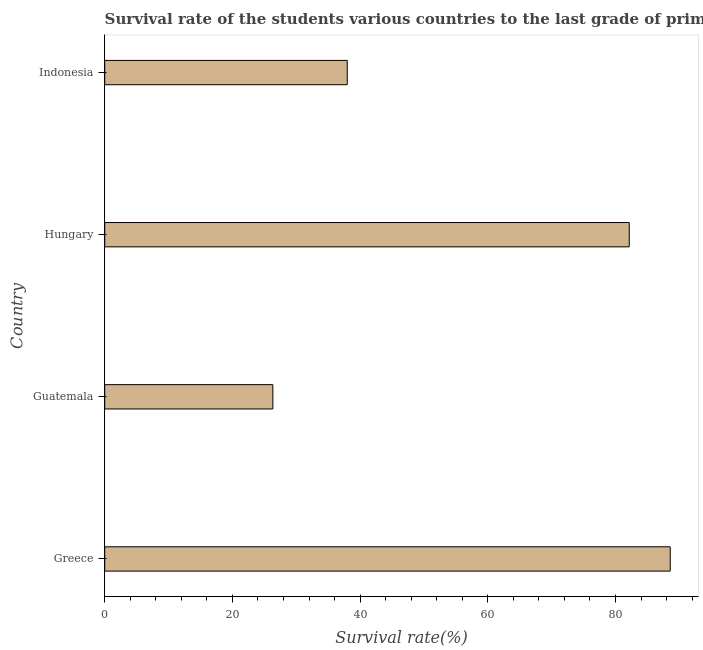Does the graph contain any zero values?
Keep it short and to the point. No. Does the graph contain grids?
Make the answer very short. No. What is the title of the graph?
Provide a short and direct response. Survival rate of the students various countries to the last grade of primary education. What is the label or title of the X-axis?
Your response must be concise. Survival rate(%). What is the survival rate in primary education in Guatemala?
Make the answer very short. 26.34. Across all countries, what is the maximum survival rate in primary education?
Provide a succinct answer. 88.57. Across all countries, what is the minimum survival rate in primary education?
Make the answer very short. 26.34. In which country was the survival rate in primary education maximum?
Offer a terse response. Greece. In which country was the survival rate in primary education minimum?
Keep it short and to the point. Guatemala. What is the sum of the survival rate in primary education?
Ensure brevity in your answer.  235.05. What is the difference between the survival rate in primary education in Greece and Indonesia?
Provide a succinct answer. 50.59. What is the average survival rate in primary education per country?
Make the answer very short. 58.76. What is the median survival rate in primary education?
Ensure brevity in your answer.  60.07. What is the ratio of the survival rate in primary education in Greece to that in Hungary?
Offer a terse response. 1.08. What is the difference between the highest and the second highest survival rate in primary education?
Offer a very short reply. 6.42. Is the sum of the survival rate in primary education in Greece and Hungary greater than the maximum survival rate in primary education across all countries?
Offer a very short reply. Yes. What is the difference between the highest and the lowest survival rate in primary education?
Make the answer very short. 62.24. How many bars are there?
Provide a succinct answer. 4. Are all the bars in the graph horizontal?
Your answer should be very brief. Yes. How many countries are there in the graph?
Give a very brief answer. 4. What is the difference between two consecutive major ticks on the X-axis?
Offer a very short reply. 20. Are the values on the major ticks of X-axis written in scientific E-notation?
Your answer should be compact. No. What is the Survival rate(%) in Greece?
Give a very brief answer. 88.57. What is the Survival rate(%) in Guatemala?
Offer a very short reply. 26.34. What is the Survival rate(%) in Hungary?
Ensure brevity in your answer.  82.16. What is the Survival rate(%) in Indonesia?
Ensure brevity in your answer.  37.99. What is the difference between the Survival rate(%) in Greece and Guatemala?
Provide a succinct answer. 62.24. What is the difference between the Survival rate(%) in Greece and Hungary?
Your answer should be very brief. 6.42. What is the difference between the Survival rate(%) in Greece and Indonesia?
Offer a terse response. 50.59. What is the difference between the Survival rate(%) in Guatemala and Hungary?
Your answer should be compact. -55.82. What is the difference between the Survival rate(%) in Guatemala and Indonesia?
Offer a terse response. -11.65. What is the difference between the Survival rate(%) in Hungary and Indonesia?
Offer a very short reply. 44.17. What is the ratio of the Survival rate(%) in Greece to that in Guatemala?
Provide a succinct answer. 3.36. What is the ratio of the Survival rate(%) in Greece to that in Hungary?
Make the answer very short. 1.08. What is the ratio of the Survival rate(%) in Greece to that in Indonesia?
Your answer should be very brief. 2.33. What is the ratio of the Survival rate(%) in Guatemala to that in Hungary?
Provide a succinct answer. 0.32. What is the ratio of the Survival rate(%) in Guatemala to that in Indonesia?
Provide a short and direct response. 0.69. What is the ratio of the Survival rate(%) in Hungary to that in Indonesia?
Your answer should be very brief. 2.16. 